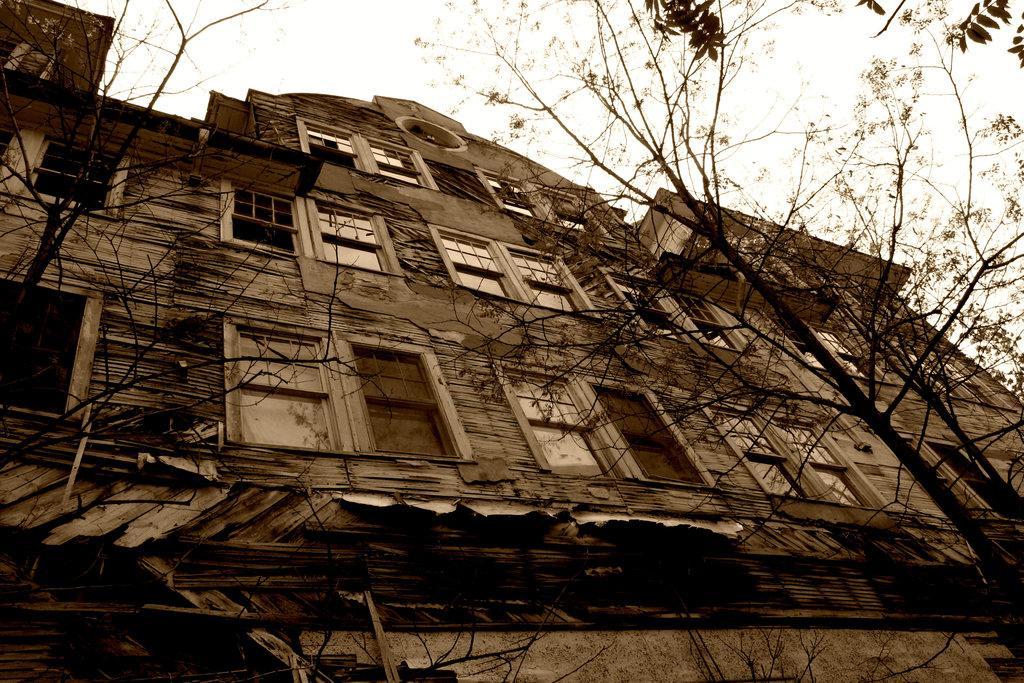Could you give a brief overview of what you see in this image? In this picture we can see a building. On the right we can see trees. On the top there is a sky. 